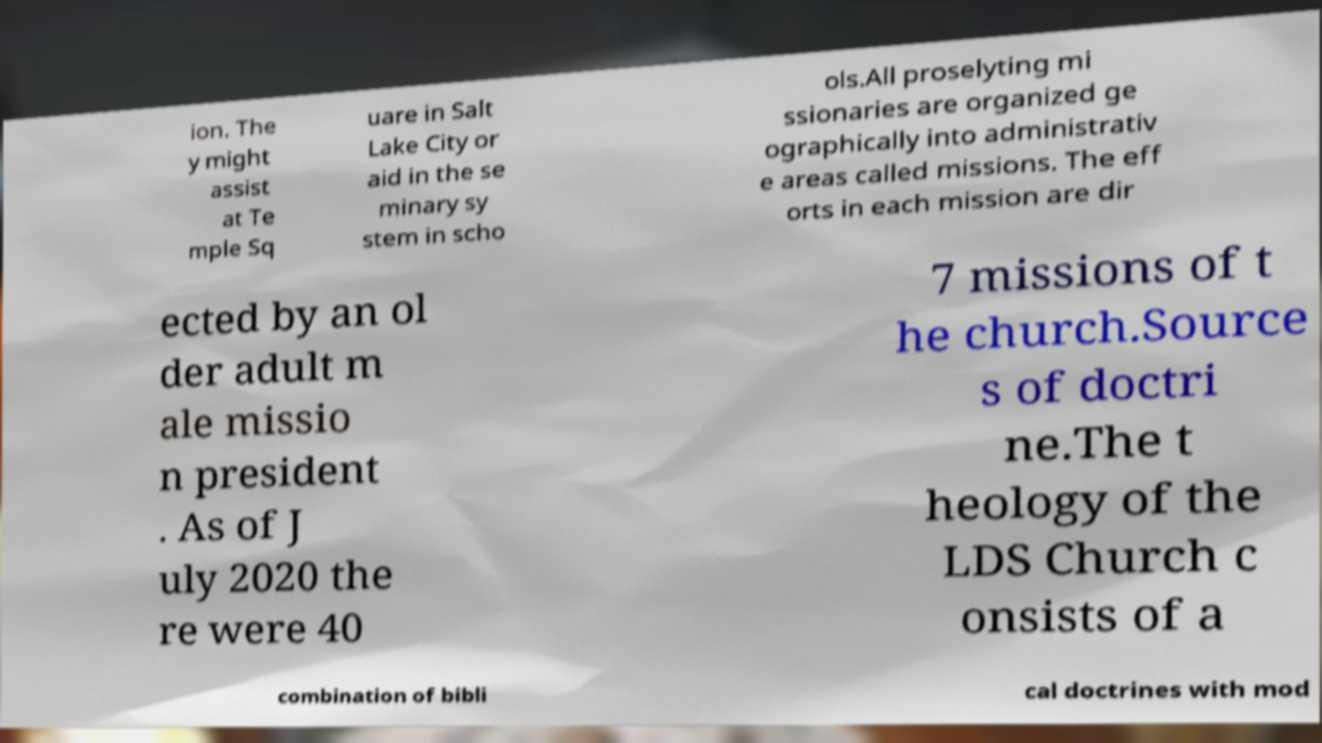Please identify and transcribe the text found in this image. ion. The y might assist at Te mple Sq uare in Salt Lake City or aid in the se minary sy stem in scho ols.All proselyting mi ssionaries are organized ge ographically into administrativ e areas called missions. The eff orts in each mission are dir ected by an ol der adult m ale missio n president . As of J uly 2020 the re were 40 7 missions of t he church.Source s of doctri ne.The t heology of the LDS Church c onsists of a combination of bibli cal doctrines with mod 